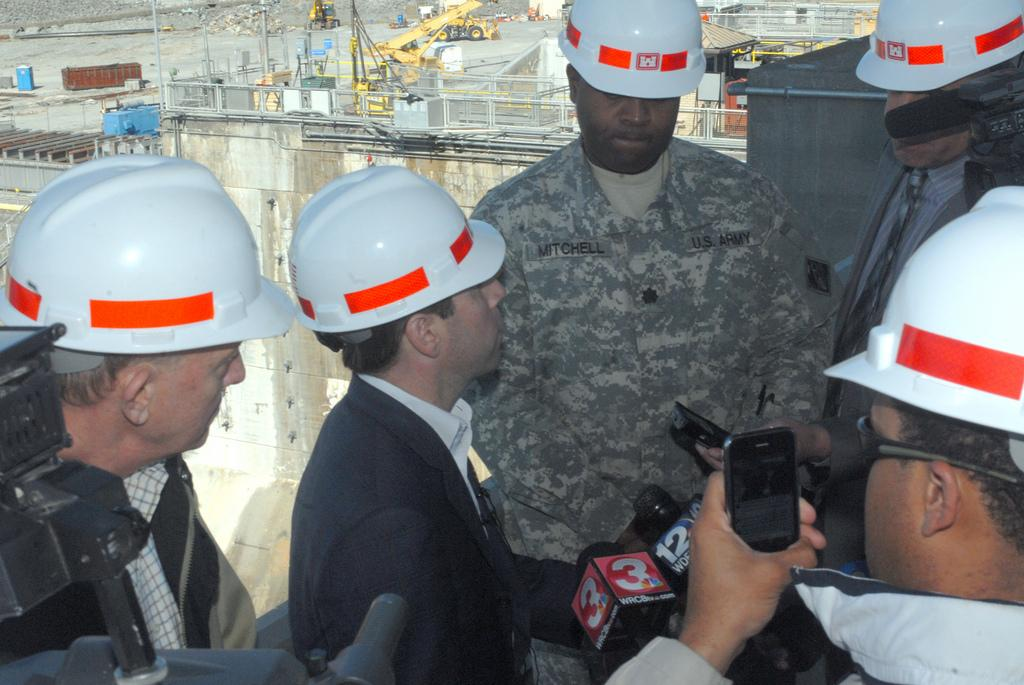What are the persons in the image wearing on their heads? The persons in the image are wearing helmets. What objects are in front of the persons in the image? There are microphones in front of the persons. What can be seen in the background of the image? There are buildings, cranes, and rocks on the surface in the background of the image. What type of roof can be seen on the buildings in the image? There is no roof visible in the image, as the focus is on the persons wearing helmets and the microphones in front of them. 